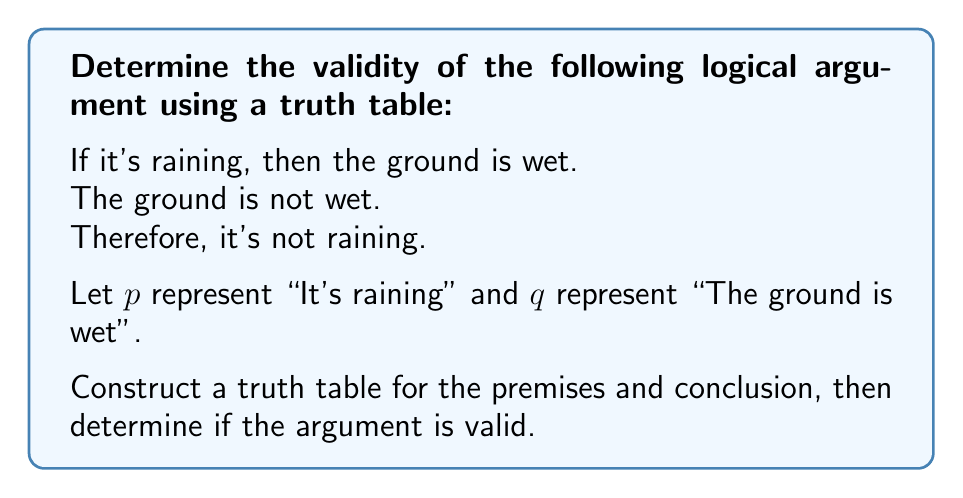Help me with this question. Let's approach this step-by-step:

1) First, we need to translate the argument into symbolic logic:
   Premise 1: $p \rightarrow q$
   Premise 2: $\neg q$
   Conclusion: $\neg p$

2) Now, let's construct the truth table:

   $$\begin{array}{|c|c|c|c|c|c|}
   \hline
   p & q & p \rightarrow q & \neg q & \neg p & \text{(P1 $\land$ P2) $\rightarrow$ C} \\
   \hline
   T & T & T & F & F & T \\
   T & F & F & T & F & T \\
   F & T & T & F & T & T \\
   F & F & T & T & T & T \\
   \hline
   \end{array}$$

3) Explanation of each column:
   - $p \rightarrow q$: This is false only when $p$ is true and $q$ is false.
   - $\neg q$: This is true when $q$ is false.
   - $\neg p$: This is true when $p$ is false.

4) The last column represents the validity of the argument. It's calculated as:
   (Premise 1 $\land$ Premise 2) $\rightarrow$ Conclusion
   
   This is equivalent to: $(p \rightarrow q) \land (\neg q) \rightarrow (\neg p)$

5) An argument is valid if and only if the last column is always true (T) for all possible combinations of truth values of $p$ and $q$.

6) As we can see, the last column is indeed all T's, which means this argument is valid.

This form of argument is known as Modus Tollens, which is a valid form of logical reasoning.
Answer: The argument is valid. 